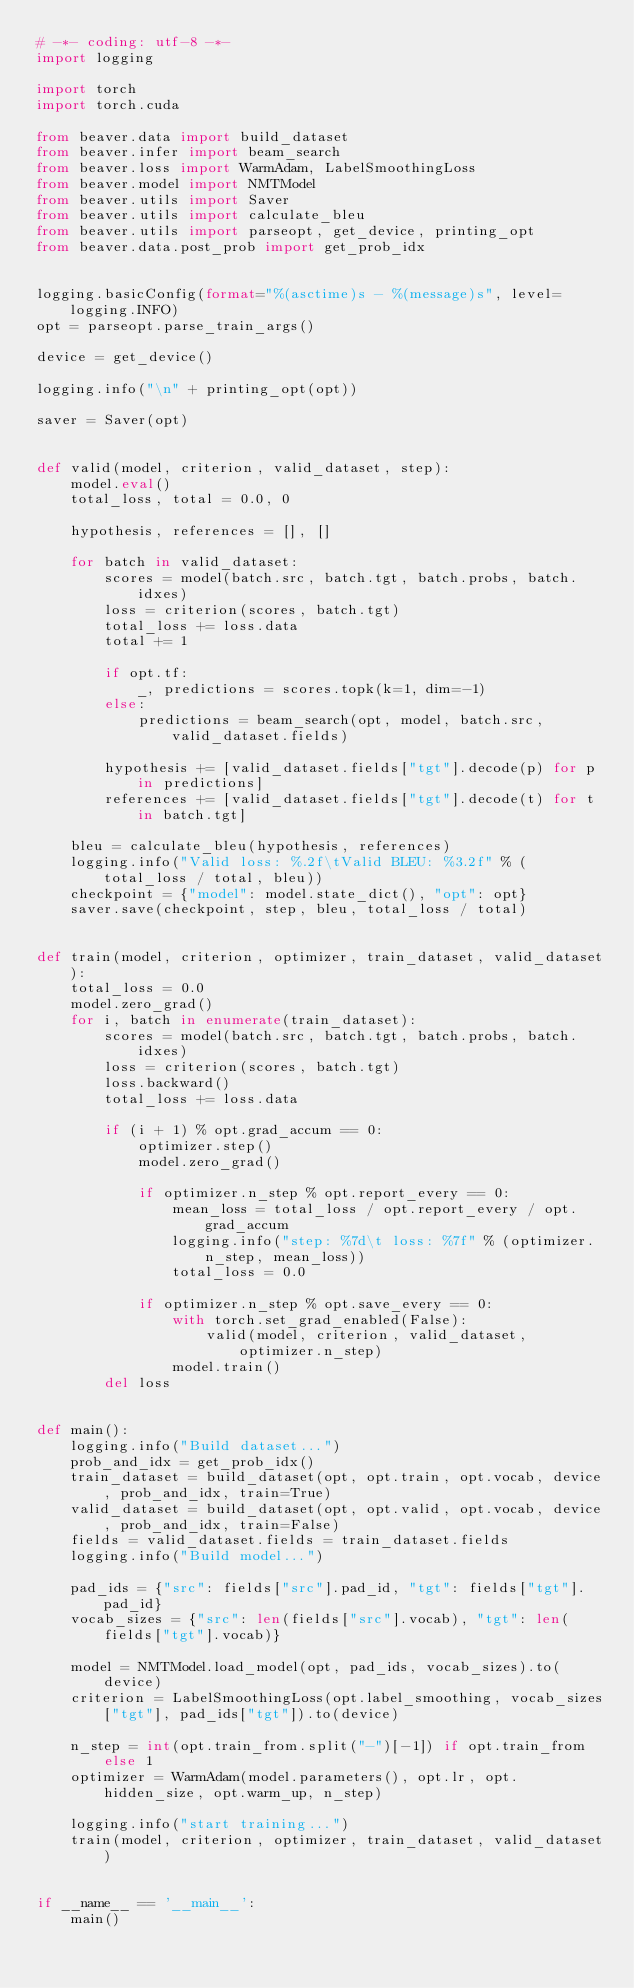Convert code to text. <code><loc_0><loc_0><loc_500><loc_500><_Python_># -*- coding: utf-8 -*-
import logging

import torch
import torch.cuda

from beaver.data import build_dataset
from beaver.infer import beam_search
from beaver.loss import WarmAdam, LabelSmoothingLoss
from beaver.model import NMTModel
from beaver.utils import Saver
from beaver.utils import calculate_bleu
from beaver.utils import parseopt, get_device, printing_opt
from beaver.data.post_prob import get_prob_idx


logging.basicConfig(format="%(asctime)s - %(message)s", level=logging.INFO)
opt = parseopt.parse_train_args()

device = get_device()

logging.info("\n" + printing_opt(opt))

saver = Saver(opt)


def valid(model, criterion, valid_dataset, step):
    model.eval()
    total_loss, total = 0.0, 0

    hypothesis, references = [], []

    for batch in valid_dataset:
        scores = model(batch.src, batch.tgt, batch.probs, batch.idxes)
        loss = criterion(scores, batch.tgt)
        total_loss += loss.data
        total += 1

        if opt.tf:
            _, predictions = scores.topk(k=1, dim=-1)
        else:
            predictions = beam_search(opt, model, batch.src, valid_dataset.fields)

        hypothesis += [valid_dataset.fields["tgt"].decode(p) for p in predictions]
        references += [valid_dataset.fields["tgt"].decode(t) for t in batch.tgt]

    bleu = calculate_bleu(hypothesis, references)
    logging.info("Valid loss: %.2f\tValid BLEU: %3.2f" % (total_loss / total, bleu))
    checkpoint = {"model": model.state_dict(), "opt": opt}
    saver.save(checkpoint, step, bleu, total_loss / total)


def train(model, criterion, optimizer, train_dataset, valid_dataset):
    total_loss = 0.0
    model.zero_grad()
    for i, batch in enumerate(train_dataset):
        scores = model(batch.src, batch.tgt, batch.probs, batch.idxes)
        loss = criterion(scores, batch.tgt)
        loss.backward()
        total_loss += loss.data

        if (i + 1) % opt.grad_accum == 0:
            optimizer.step()
            model.zero_grad()

            if optimizer.n_step % opt.report_every == 0:
                mean_loss = total_loss / opt.report_every / opt.grad_accum
                logging.info("step: %7d\t loss: %7f" % (optimizer.n_step, mean_loss))
                total_loss = 0.0

            if optimizer.n_step % opt.save_every == 0:
                with torch.set_grad_enabled(False):
                    valid(model, criterion, valid_dataset, optimizer.n_step)
                model.train()
        del loss


def main():
    logging.info("Build dataset...")
    prob_and_idx = get_prob_idx()
    train_dataset = build_dataset(opt, opt.train, opt.vocab, device, prob_and_idx, train=True)
    valid_dataset = build_dataset(opt, opt.valid, opt.vocab, device, prob_and_idx, train=False)
    fields = valid_dataset.fields = train_dataset.fields
    logging.info("Build model...")

    pad_ids = {"src": fields["src"].pad_id, "tgt": fields["tgt"].pad_id}
    vocab_sizes = {"src": len(fields["src"].vocab), "tgt": len(fields["tgt"].vocab)}

    model = NMTModel.load_model(opt, pad_ids, vocab_sizes).to(device)
    criterion = LabelSmoothingLoss(opt.label_smoothing, vocab_sizes["tgt"], pad_ids["tgt"]).to(device)

    n_step = int(opt.train_from.split("-")[-1]) if opt.train_from else 1
    optimizer = WarmAdam(model.parameters(), opt.lr, opt.hidden_size, opt.warm_up, n_step)

    logging.info("start training...")
    train(model, criterion, optimizer, train_dataset, valid_dataset)


if __name__ == '__main__':
    main()
</code> 